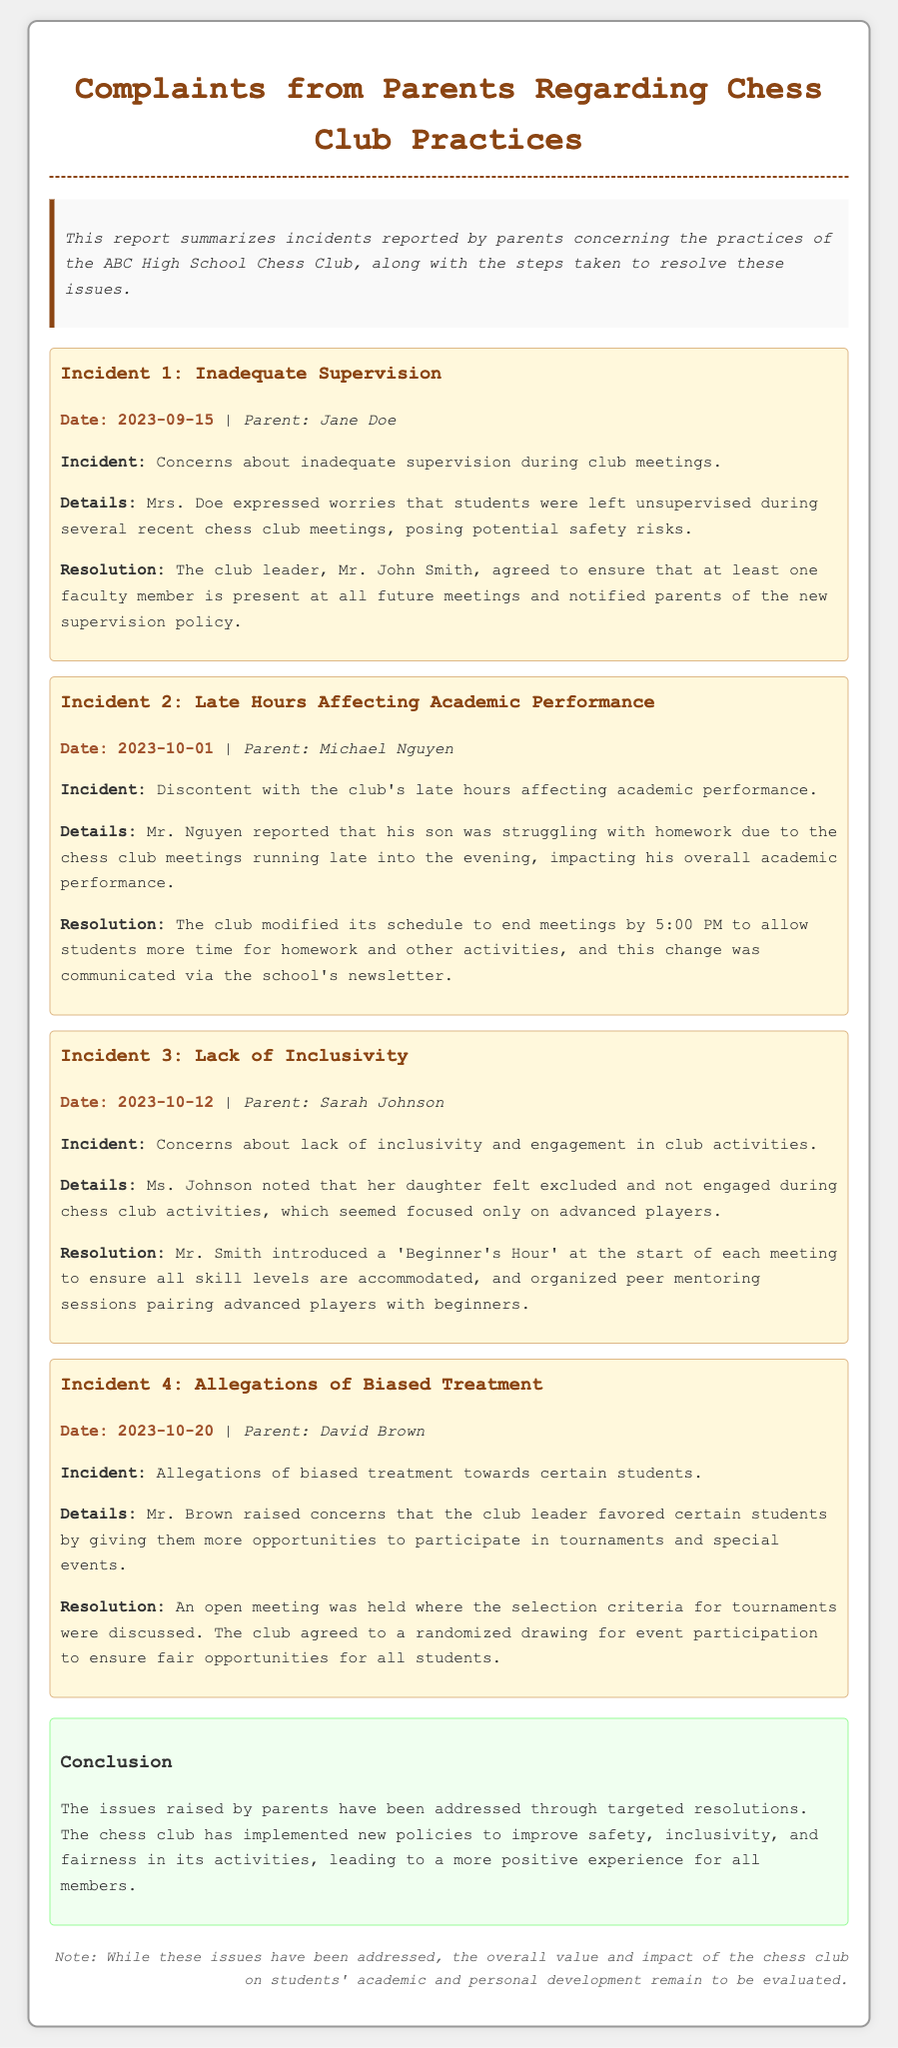What is the date of the first incident? The date of the first incident is mentioned as 2023-09-15 in the document.
Answer: 2023-09-15 Who reported concerns about inadequate supervision? The parent who reported concerns about inadequate supervision is mentioned as Jane Doe.
Answer: Jane Doe What was the resolution for the incident regarding late hours? The club modified its schedule to end meetings by 5:00 PM as a resolution for the late hours incident.
Answer: End meetings by 5:00 PM What new activity was introduced to address inclusivity concerns? A 'Beginner's Hour' was introduced to accommodate all skill levels for the inclusivity concerns.
Answer: Beginner's Hour How many incidents are summarized in the report? The report summarizes a total of four incidents regarding the Chess Club practices.
Answer: Four What did David Brown allege about the treatment of students? David Brown alleged biased treatment towards certain students in the tournament selection process.
Answer: Biased treatment Which parent expressed worries about their child's academic performance? Michael Nguyen expressed worries about his son's academic performance due to the chess club's late hours.
Answer: Michael Nguyen What was the conclusion of the report? The conclusion of the report states that the issues raised have been addressed through targeted resolutions.
Answer: Issues addressed through resolutions 